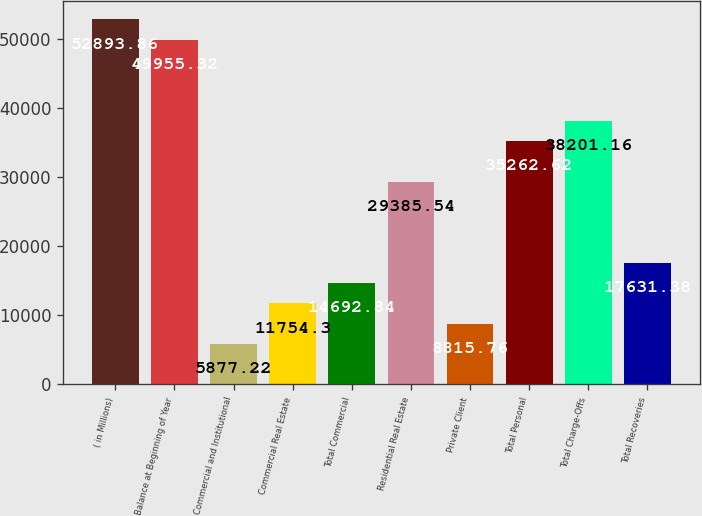Convert chart. <chart><loc_0><loc_0><loc_500><loc_500><bar_chart><fcel>( in Millions)<fcel>Balance at Beginning of Year<fcel>Commercial and Institutional<fcel>Commercial Real Estate<fcel>Total Commercial<fcel>Residential Real Estate<fcel>Private Client<fcel>Total Personal<fcel>Total Charge-Offs<fcel>Total Recoveries<nl><fcel>52893.9<fcel>49955.3<fcel>5877.22<fcel>11754.3<fcel>14692.8<fcel>29385.5<fcel>8815.76<fcel>35262.6<fcel>38201.2<fcel>17631.4<nl></chart> 